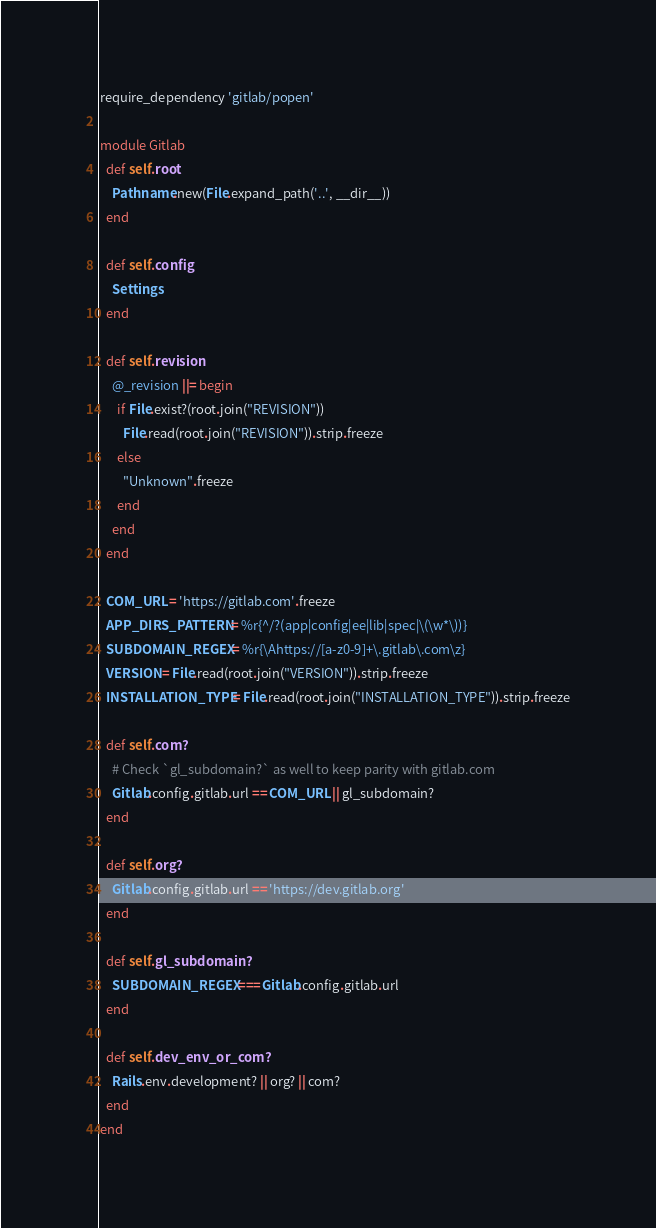<code> <loc_0><loc_0><loc_500><loc_500><_Ruby_>require_dependency 'gitlab/popen'

module Gitlab
  def self.root
    Pathname.new(File.expand_path('..', __dir__))
  end

  def self.config
    Settings
  end

  def self.revision
    @_revision ||= begin
      if File.exist?(root.join("REVISION"))
        File.read(root.join("REVISION")).strip.freeze
      else
        "Unknown".freeze
      end
    end
  end

  COM_URL = 'https://gitlab.com'.freeze
  APP_DIRS_PATTERN = %r{^/?(app|config|ee|lib|spec|\(\w*\))}
  SUBDOMAIN_REGEX = %r{\Ahttps://[a-z0-9]+\.gitlab\.com\z}
  VERSION = File.read(root.join("VERSION")).strip.freeze
  INSTALLATION_TYPE = File.read(root.join("INSTALLATION_TYPE")).strip.freeze

  def self.com?
    # Check `gl_subdomain?` as well to keep parity with gitlab.com
    Gitlab.config.gitlab.url == COM_URL || gl_subdomain?
  end

  def self.org?
    Gitlab.config.gitlab.url == 'https://dev.gitlab.org'
  end

  def self.gl_subdomain?
    SUBDOMAIN_REGEX === Gitlab.config.gitlab.url
  end

  def self.dev_env_or_com?
    Rails.env.development? || org? || com?
  end
end
</code> 